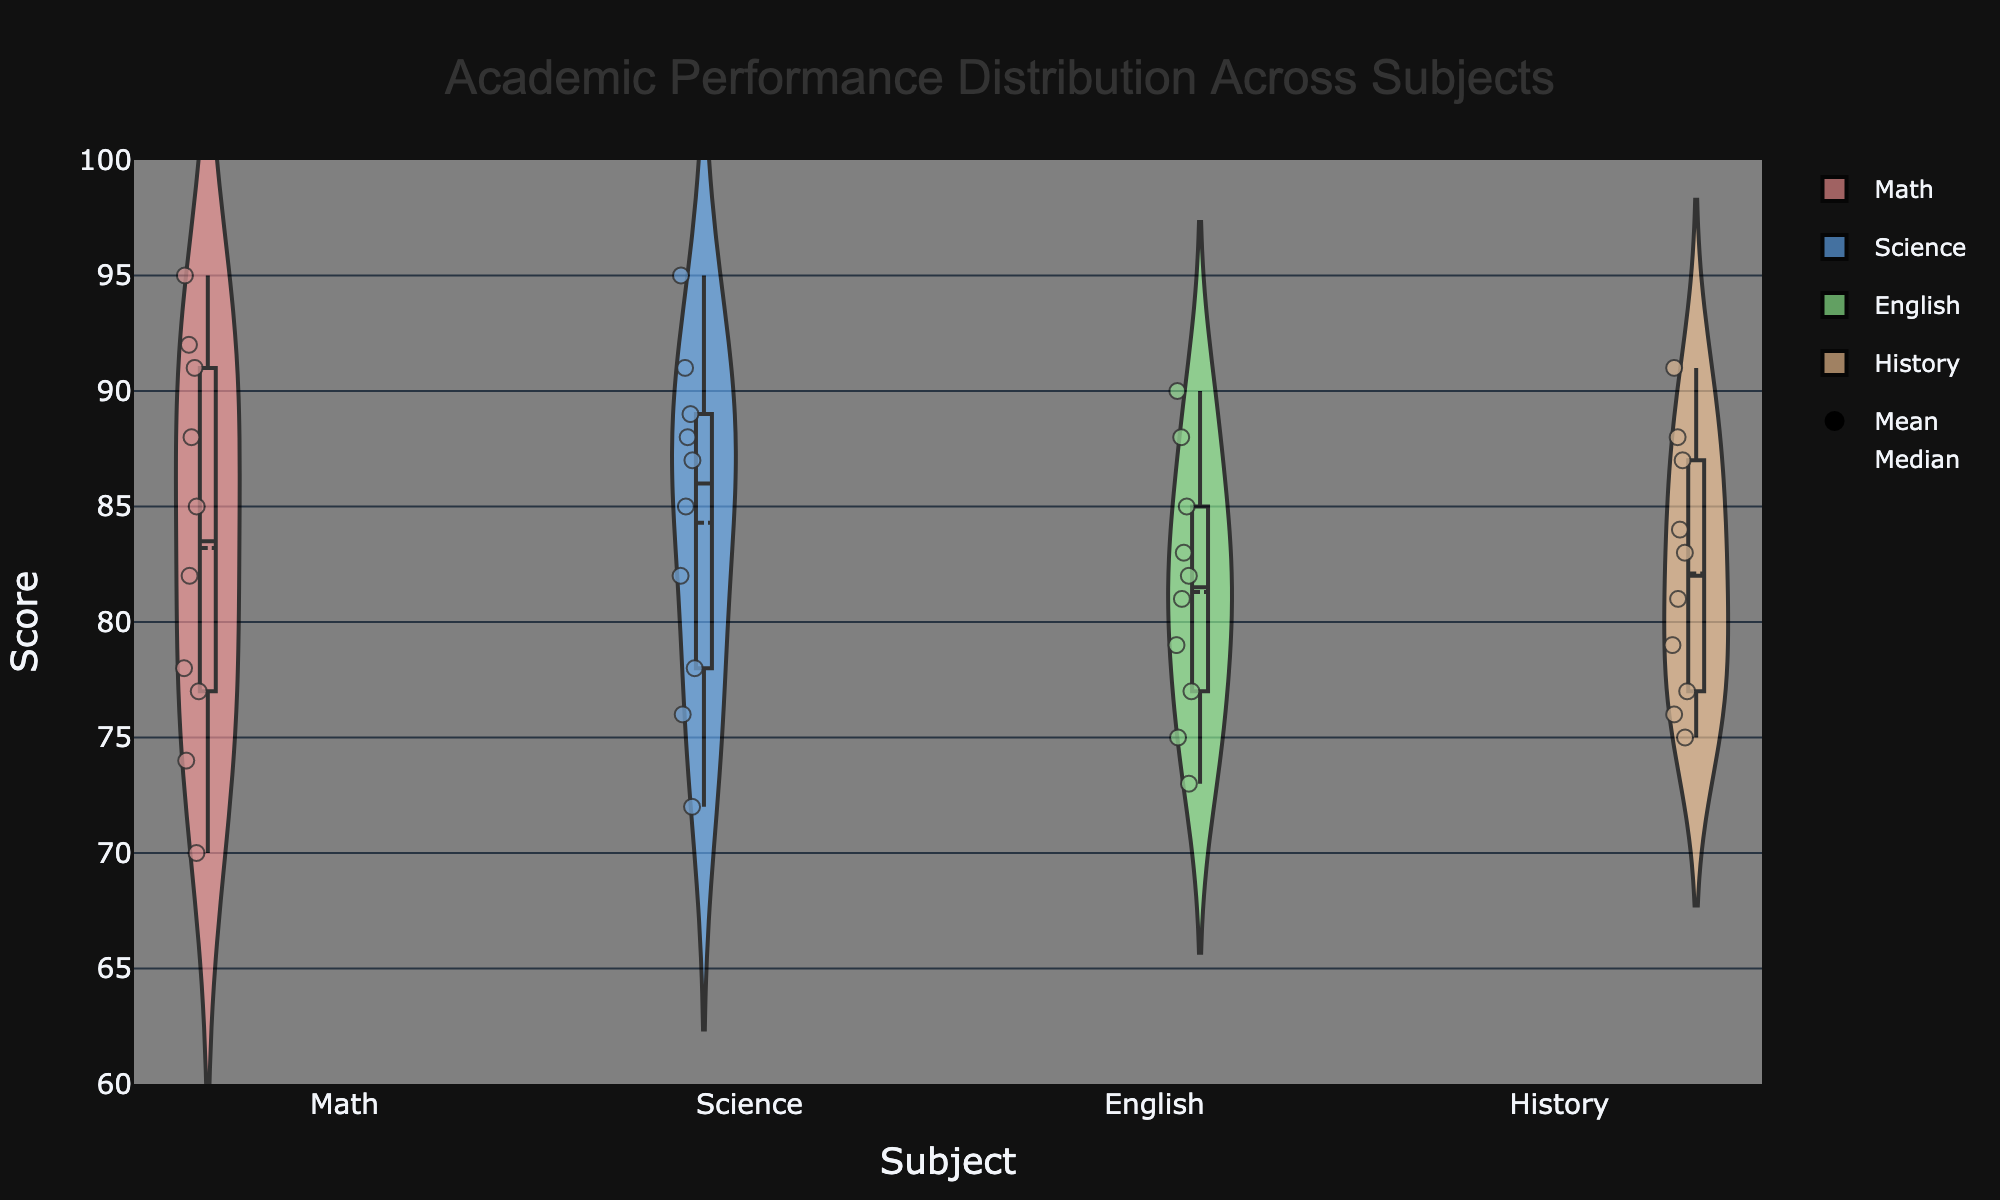What is the title of the chart? The title of the chart is usually positioned at the top of the figure. In this case, it reads "Academic Performance Distribution Across Subjects".
Answer: Academic Performance Distribution Across Subjects What is the range of scores on the y-axis? The range of the scores on the y-axis is typically noted along the vertical line on the left side. The y-axis in this figure ranges from 60 to 100.
Answer: 60 to 100 Which subject has the highest average score? To determine the highest average score, look for the mean line in each violin plot. The subject with the highest line represents the highest average score. In this chart, the mean line in the science violin plot is the highest.
Answer: Science In which subject is the difference between the mean and median scores the largest? To find this, observe the distance between the mean line and median line in each violin plot. The subject with the largest distance between these lines has the greatest difference. The math subject shows the largest difference between the mean and median lines.
Answer: Math Which subject has the most evenly distributed scores? An evenly distributed score will have a symmetrical and similar spread throughout the violin plot without significant narrowing or widening. Here, the violin plot for English appears the most symmetrical and evenly distributed.
Answer: English What is the median score in History? To find the median score, look for the line in the middle of the History violin plot. The median line represents the middle value when all scores are ordered from lowest to highest. In this chart, the median score for History is 81.
Answer: 81 Which subject shows the most variability in academic performance? The variability in a subject's performance is shown by the width and spread of the violin plot. The wider and more spread out the plot, the greater the variability. Science has the widest spread, indicating the most variability.
Answer: Science Are there any subjects where the lowest score is above 70? To check this, look at the bottom of each violin plot for the lowest points represented. In this chart, all subjects have scores above 70, except for Math and English.
Answer: Yes Which subject has the narrowest interquartile range (IQR)? The IQR is the range between the first quartile and the third quartile, depicted by the box within the violin plot. The narrower the box, the smaller the IQR. English has the narrowest interquartile range in this chart.
Answer: English 